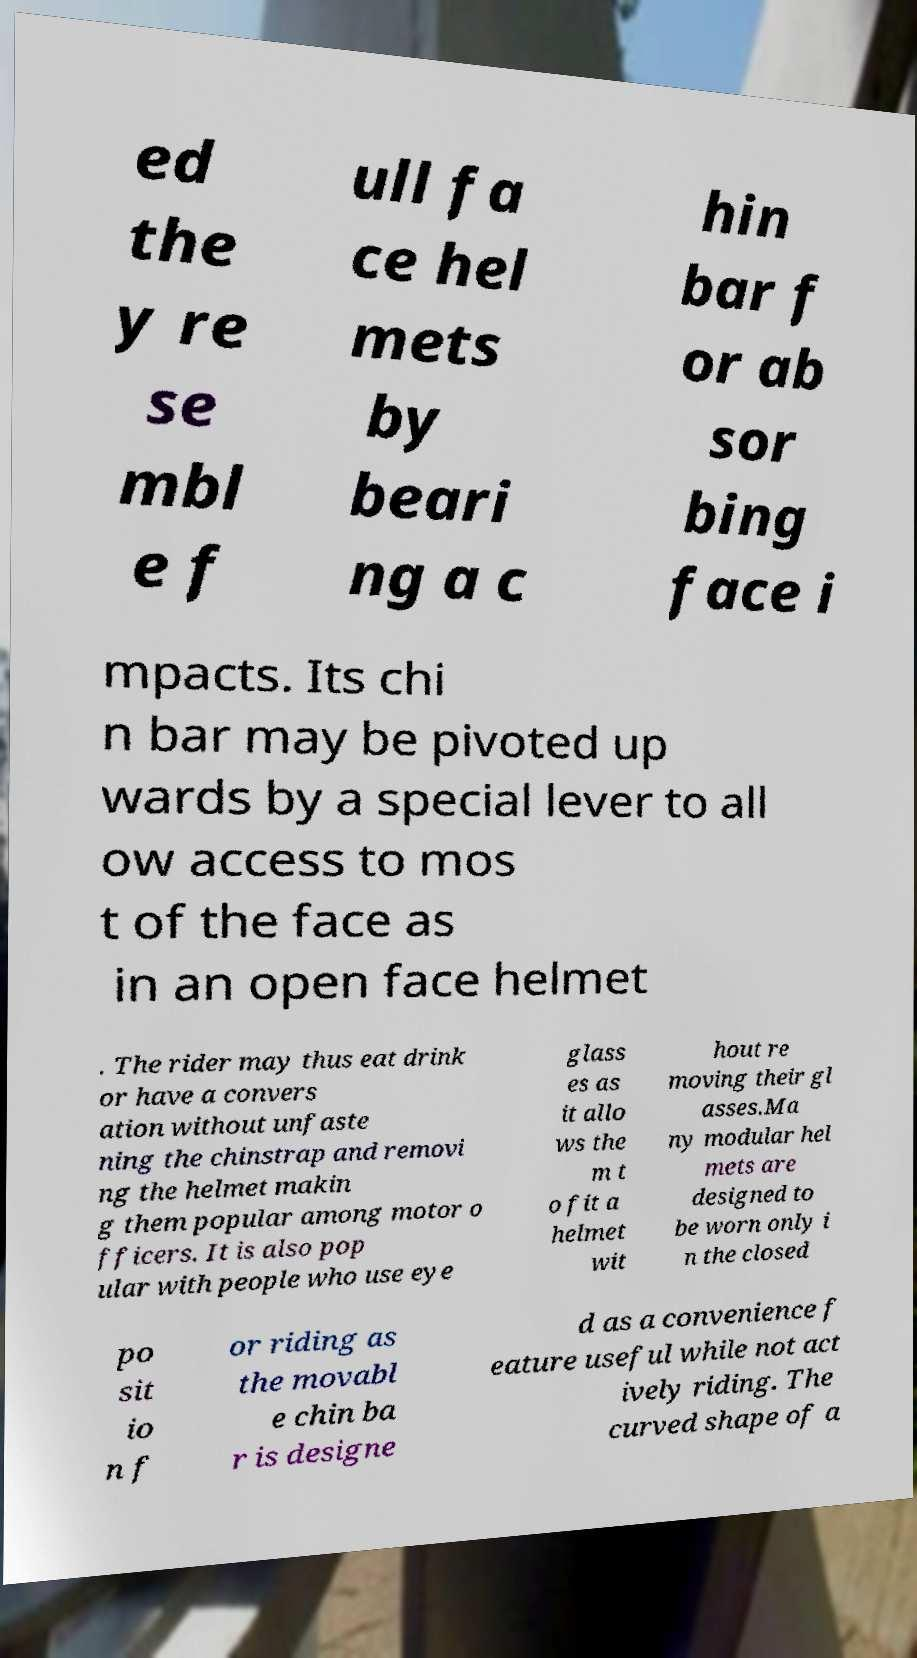What messages or text are displayed in this image? I need them in a readable, typed format. ed the y re se mbl e f ull fa ce hel mets by beari ng a c hin bar f or ab sor bing face i mpacts. Its chi n bar may be pivoted up wards by a special lever to all ow access to mos t of the face as in an open face helmet . The rider may thus eat drink or have a convers ation without unfaste ning the chinstrap and removi ng the helmet makin g them popular among motor o fficers. It is also pop ular with people who use eye glass es as it allo ws the m t o fit a helmet wit hout re moving their gl asses.Ma ny modular hel mets are designed to be worn only i n the closed po sit io n f or riding as the movabl e chin ba r is designe d as a convenience f eature useful while not act ively riding. The curved shape of a 